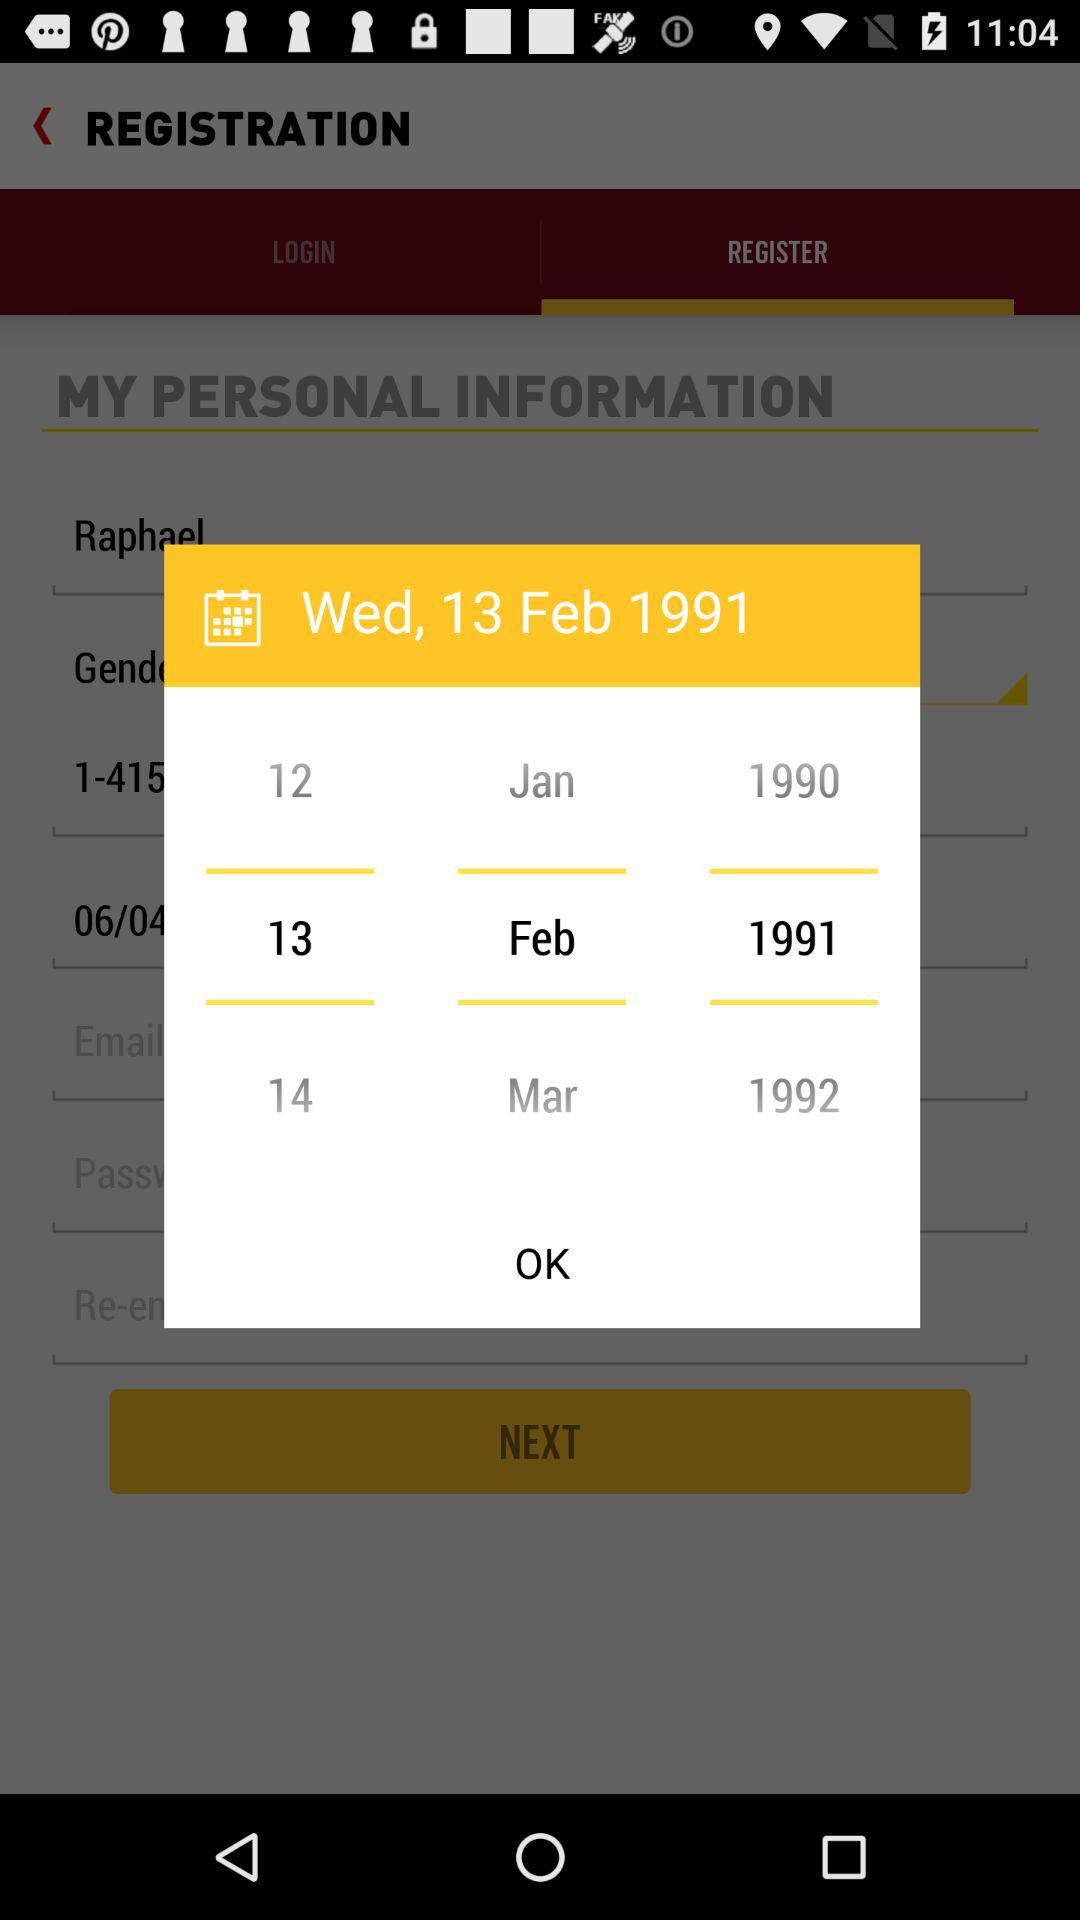What could this screenshot indicate about the app or the user? This screenshot suggests that the user is in the process of registering for an account with an application, and part of the registration involves entering personal information such as a birthdate. Is there anything unique about the design of the date picker? The date picker has a user-friendly design that allows for a quick selection of day, month, and year, which are clearly separated into different columns for ease of use. 